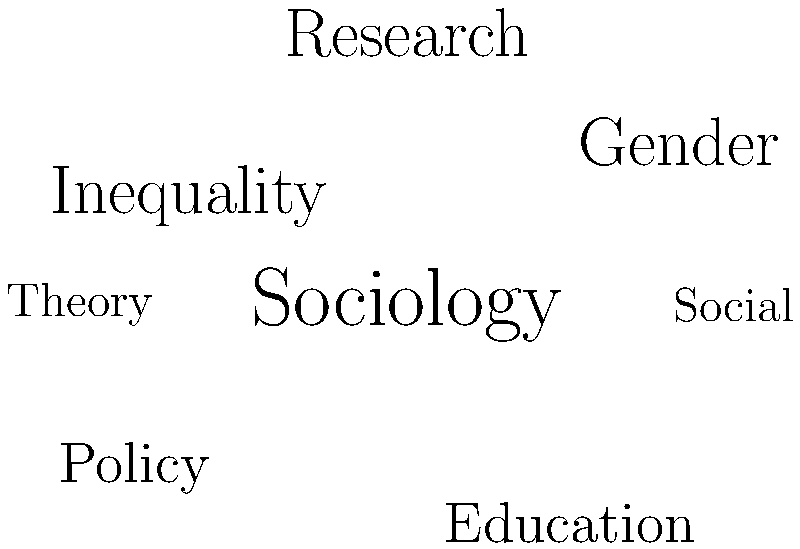Based on the word cloud representation of your research interests, which area appears to be the most prominent focus of your academic work? To determine the most prominent focus of Jennifer McArton's research interests based on the word cloud, we need to analyze the visual representation:

1. Observe the size of each word: In word clouds, the size of a word typically corresponds to its importance or frequency.
2. Identify the largest word: In this word cloud, "Sociology" appears to be the largest word.
3. Consider the position: Central or prominent positions often indicate greater importance. "Sociology" is centrally located.
4. Compare with other words: Other significant words like "Gender," "Inequality," and "Research" are smaller than "Sociology."
5. Interpret the context: The presence of words like "Gender," "Inequality," "Education," and "Policy" suggests that these are subtopics within the broader field of Sociology.

Given these observations, we can conclude that Sociology is the most prominent focus of Jennifer McArton's academic work, as it encompasses the other topics represented in the word cloud.
Answer: Sociology 